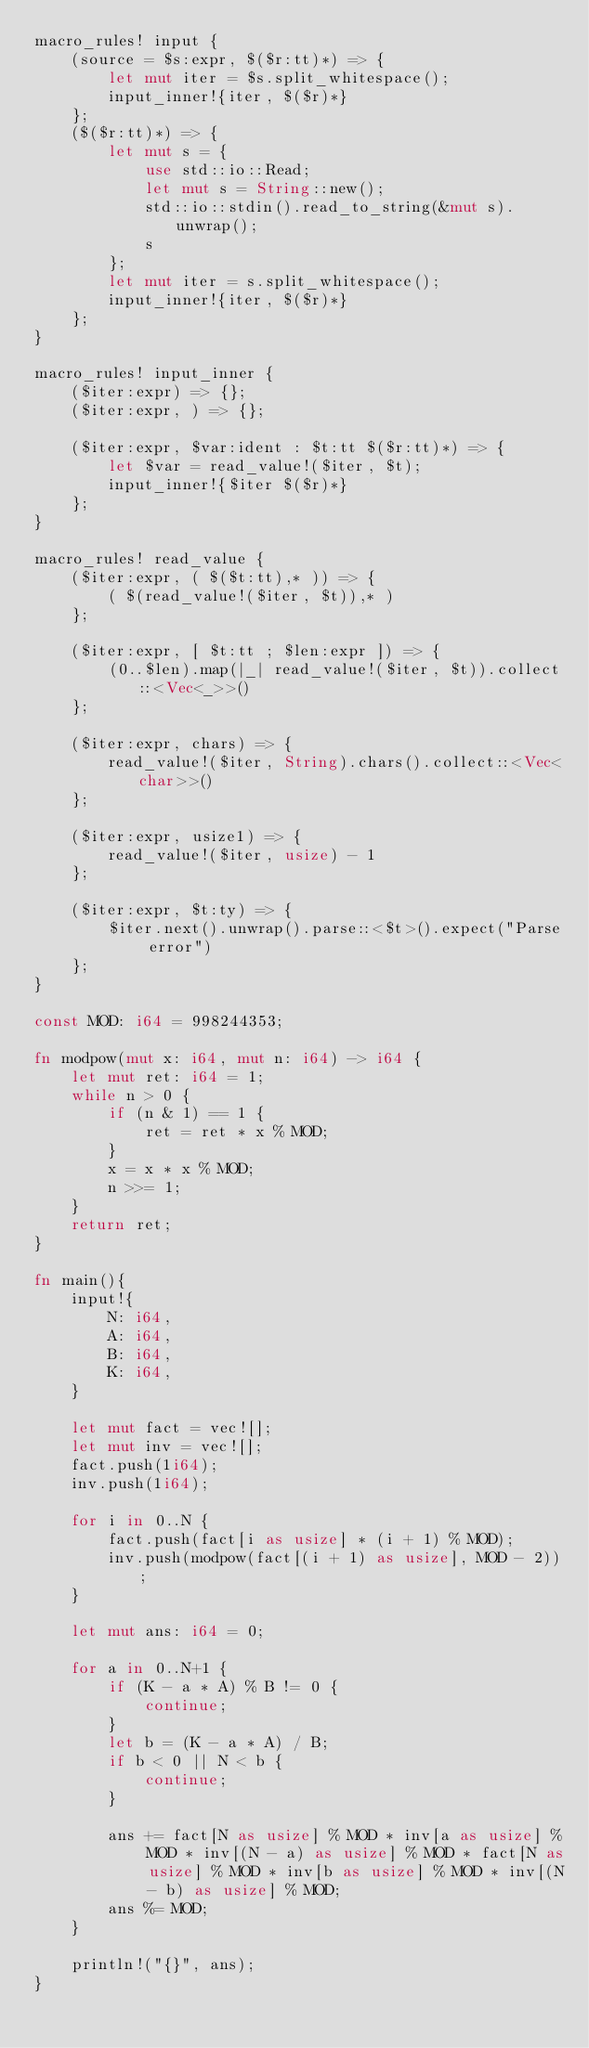<code> <loc_0><loc_0><loc_500><loc_500><_Rust_>macro_rules! input {
    (source = $s:expr, $($r:tt)*) => {
        let mut iter = $s.split_whitespace();
        input_inner!{iter, $($r)*}
    };
    ($($r:tt)*) => {
        let mut s = {
            use std::io::Read;
            let mut s = String::new();
            std::io::stdin().read_to_string(&mut s).unwrap();
            s
        };
        let mut iter = s.split_whitespace();
        input_inner!{iter, $($r)*}
    };
}

macro_rules! input_inner {
    ($iter:expr) => {};
    ($iter:expr, ) => {};

    ($iter:expr, $var:ident : $t:tt $($r:tt)*) => {
        let $var = read_value!($iter, $t);
        input_inner!{$iter $($r)*}
    };
}

macro_rules! read_value {
    ($iter:expr, ( $($t:tt),* )) => {
        ( $(read_value!($iter, $t)),* )
    };

    ($iter:expr, [ $t:tt ; $len:expr ]) => {
        (0..$len).map(|_| read_value!($iter, $t)).collect::<Vec<_>>()
    };

    ($iter:expr, chars) => {
        read_value!($iter, String).chars().collect::<Vec<char>>()
    };

    ($iter:expr, usize1) => {
        read_value!($iter, usize) - 1
    };

    ($iter:expr, $t:ty) => {
        $iter.next().unwrap().parse::<$t>().expect("Parse error")
    };
}

const MOD: i64 = 998244353;

fn modpow(mut x: i64, mut n: i64) -> i64 {
    let mut ret: i64 = 1;
    while n > 0 {
        if (n & 1) == 1 {
            ret = ret * x % MOD;
        }
        x = x * x % MOD;
        n >>= 1;
    }
    return ret;
}

fn main(){
    input!{
        N: i64,
        A: i64,
        B: i64,
        K: i64,
    }

    let mut fact = vec![];
    let mut inv = vec![];
    fact.push(1i64);
    inv.push(1i64);

    for i in 0..N {
        fact.push(fact[i as usize] * (i + 1) % MOD);
        inv.push(modpow(fact[(i + 1) as usize], MOD - 2));
    }

    let mut ans: i64 = 0;

    for a in 0..N+1 {
        if (K - a * A) % B != 0 {
            continue;
        }
        let b = (K - a * A) / B;
        if b < 0 || N < b {
            continue;
        }

        ans += fact[N as usize] % MOD * inv[a as usize] % MOD * inv[(N - a) as usize] % MOD * fact[N as usize] % MOD * inv[b as usize] % MOD * inv[(N - b) as usize] % MOD;
        ans %= MOD;
    }

    println!("{}", ans);
}</code> 